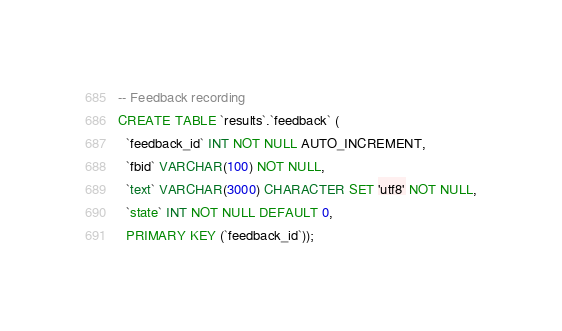<code> <loc_0><loc_0><loc_500><loc_500><_SQL_>-- Feedback recording
CREATE TABLE `results`.`feedback` (
  `feedback_id` INT NOT NULL AUTO_INCREMENT,
  `fbid` VARCHAR(100) NOT NULL,
  `text` VARCHAR(3000) CHARACTER SET 'utf8' NOT NULL,
  `state` INT NOT NULL DEFAULT 0,
  PRIMARY KEY (`feedback_id`));
</code> 